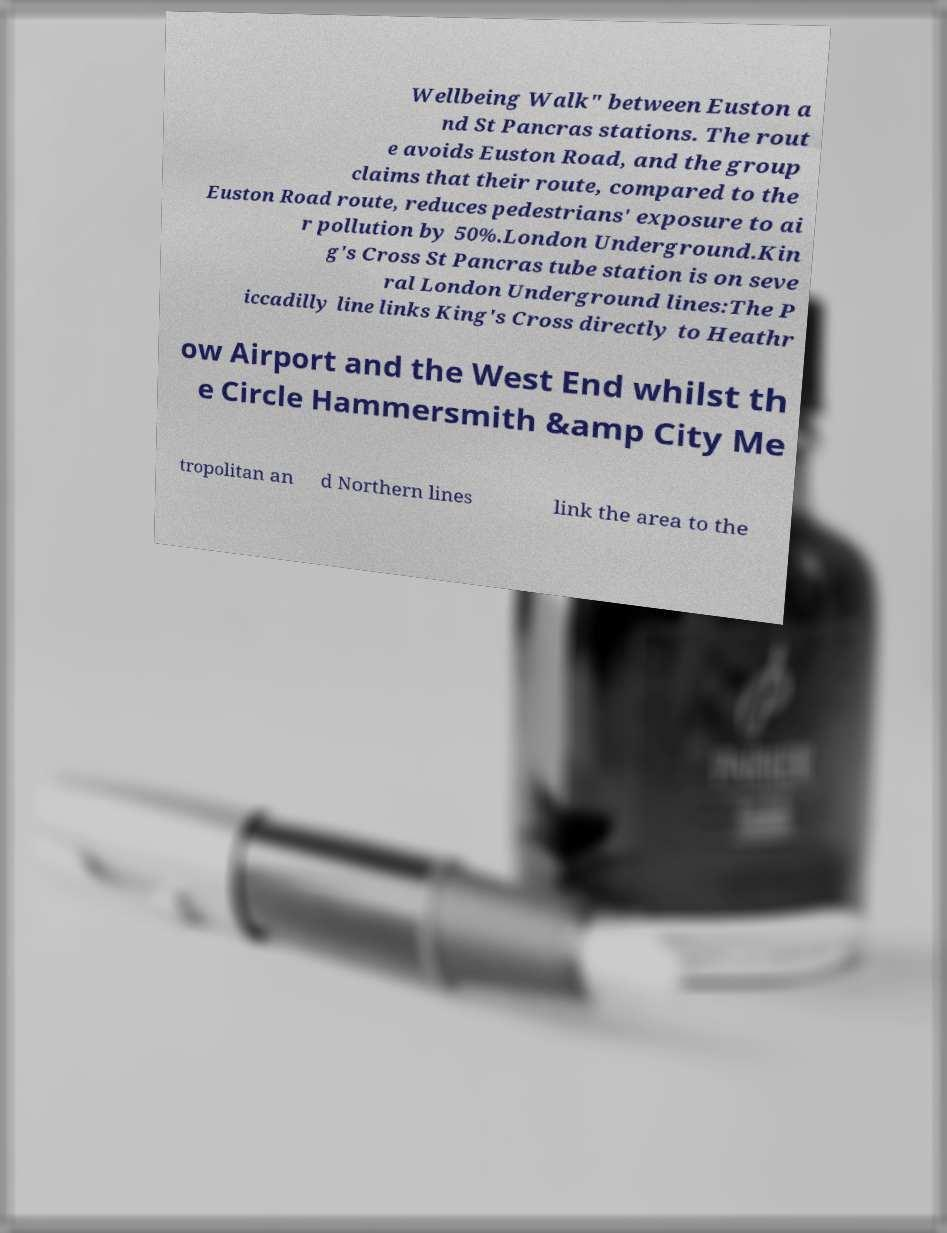Please read and relay the text visible in this image. What does it say? Wellbeing Walk" between Euston a nd St Pancras stations. The rout e avoids Euston Road, and the group claims that their route, compared to the Euston Road route, reduces pedestrians' exposure to ai r pollution by 50%.London Underground.Kin g's Cross St Pancras tube station is on seve ral London Underground lines:The P iccadilly line links King's Cross directly to Heathr ow Airport and the West End whilst th e Circle Hammersmith &amp City Me tropolitan an d Northern lines link the area to the 